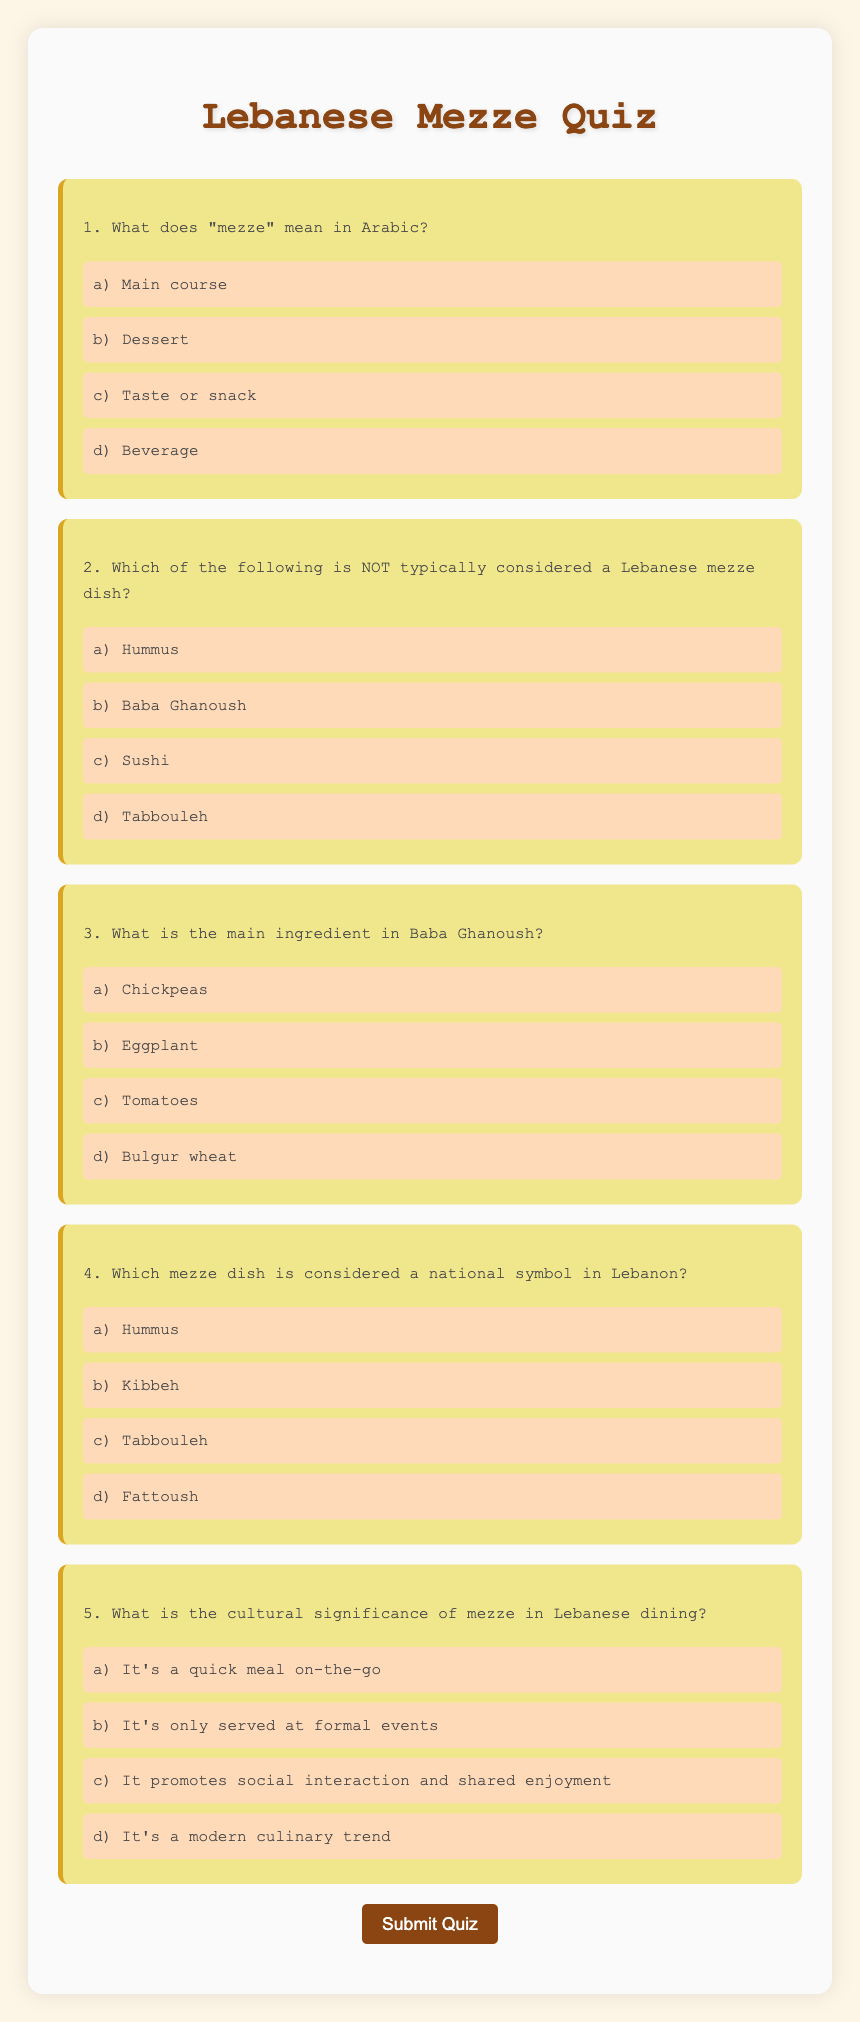What does "mezze" mean in Arabic? The document defines "mezze" as "taste or snack" in Arabic.
Answer: taste or snack Which dish is NOT considered a Lebanese mezze? The document lists sushi among the options, indicating it is NOT a Lebanese mezze dish.
Answer: Sushi What is the main ingredient in Baba Ghanoush? The document explicitly states that eggplant is the main ingredient in Baba Ghanoush.
Answer: Eggplant Which mezze dish is considered a national symbol in Lebanon? The document identifies hummus as the mezze dish considered a national symbol in Lebanon.
Answer: Hummus What is the cultural significance of mezze in Lebanese dining? The document explains that mezze promotes social interaction and shared enjoyment in Lebanese dining.
Answer: Social interaction and shared enjoyment 